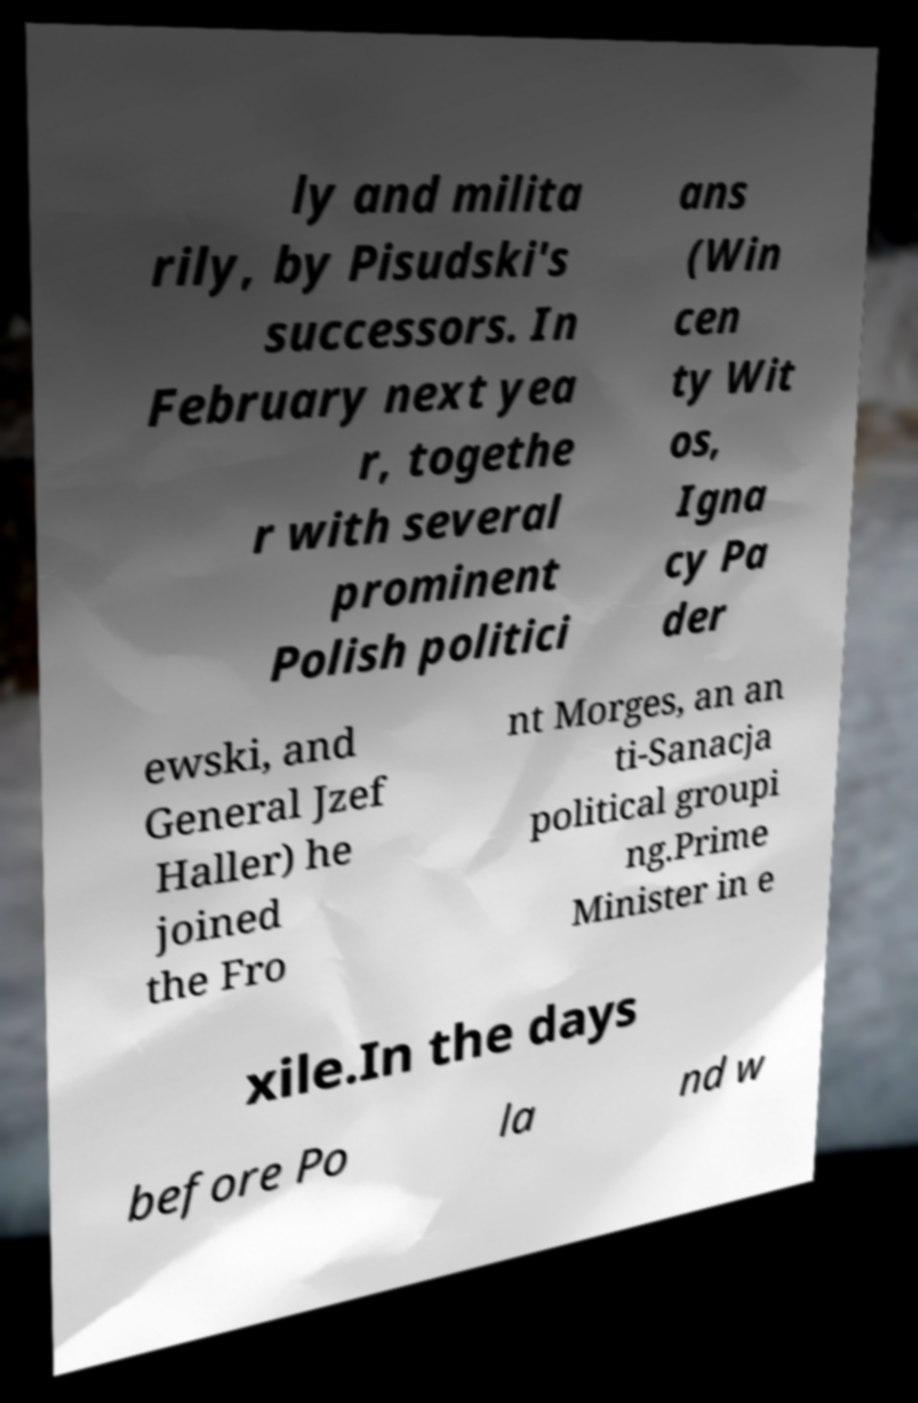I need the written content from this picture converted into text. Can you do that? ly and milita rily, by Pisudski's successors. In February next yea r, togethe r with several prominent Polish politici ans (Win cen ty Wit os, Igna cy Pa der ewski, and General Jzef Haller) he joined the Fro nt Morges, an an ti-Sanacja political groupi ng.Prime Minister in e xile.In the days before Po la nd w 